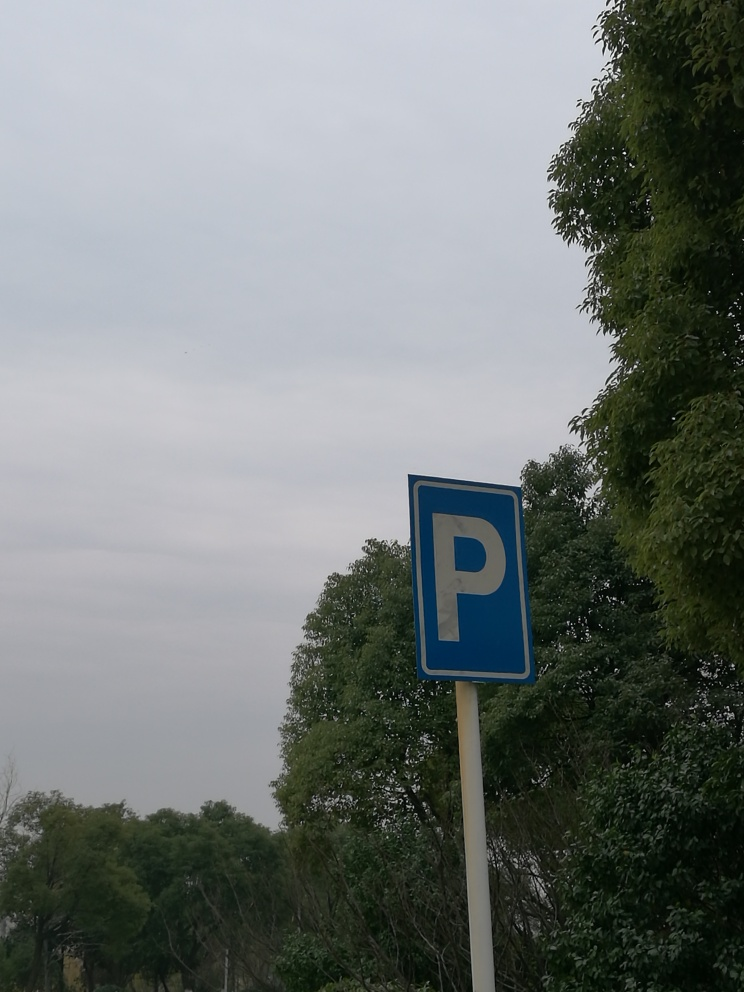What other signs or symbols might you expect to find near this parking area? One might expect additional signage to regulate the parking area, such as time limits, payment requirements, reserved parking for the disabled, parent child parking, or instructional signs for proper usage of the space. 